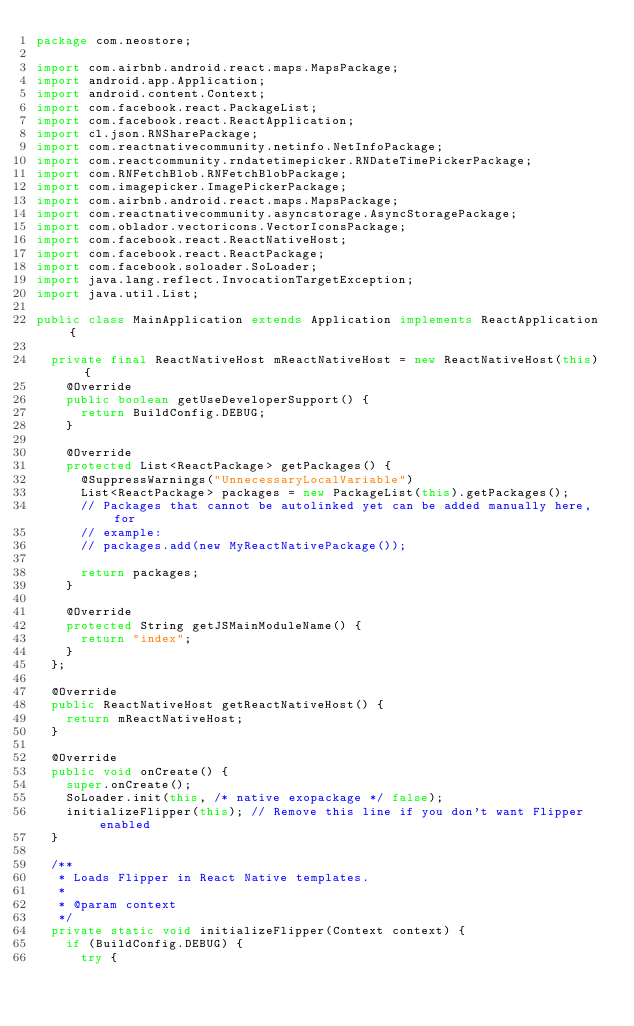Convert code to text. <code><loc_0><loc_0><loc_500><loc_500><_Java_>package com.neostore;

import com.airbnb.android.react.maps.MapsPackage;
import android.app.Application;
import android.content.Context;
import com.facebook.react.PackageList;
import com.facebook.react.ReactApplication;
import cl.json.RNSharePackage;
import com.reactnativecommunity.netinfo.NetInfoPackage;
import com.reactcommunity.rndatetimepicker.RNDateTimePickerPackage;
import com.RNFetchBlob.RNFetchBlobPackage;
import com.imagepicker.ImagePickerPackage;
import com.airbnb.android.react.maps.MapsPackage;
import com.reactnativecommunity.asyncstorage.AsyncStoragePackage;
import com.oblador.vectoricons.VectorIconsPackage;
import com.facebook.react.ReactNativeHost;
import com.facebook.react.ReactPackage;
import com.facebook.soloader.SoLoader;
import java.lang.reflect.InvocationTargetException;
import java.util.List;

public class MainApplication extends Application implements ReactApplication {

  private final ReactNativeHost mReactNativeHost = new ReactNativeHost(this) {
    @Override
    public boolean getUseDeveloperSupport() {
      return BuildConfig.DEBUG;
    }

    @Override
    protected List<ReactPackage> getPackages() {
      @SuppressWarnings("UnnecessaryLocalVariable")
      List<ReactPackage> packages = new PackageList(this).getPackages();
      // Packages that cannot be autolinked yet can be added manually here, for
      // example:
      // packages.add(new MyReactNativePackage());

      return packages;
    }

    @Override
    protected String getJSMainModuleName() {
      return "index";
    }
  };

  @Override
  public ReactNativeHost getReactNativeHost() {
    return mReactNativeHost;
  }

  @Override
  public void onCreate() {
    super.onCreate();
    SoLoader.init(this, /* native exopackage */ false);
    initializeFlipper(this); // Remove this line if you don't want Flipper enabled
  }

  /**
   * Loads Flipper in React Native templates.
   *
   * @param context
   */
  private static void initializeFlipper(Context context) {
    if (BuildConfig.DEBUG) {
      try {</code> 